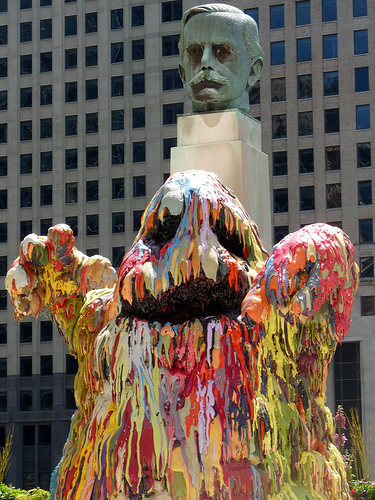<image>
Is the monster next to the building? Yes. The monster is positioned adjacent to the building, located nearby in the same general area. 